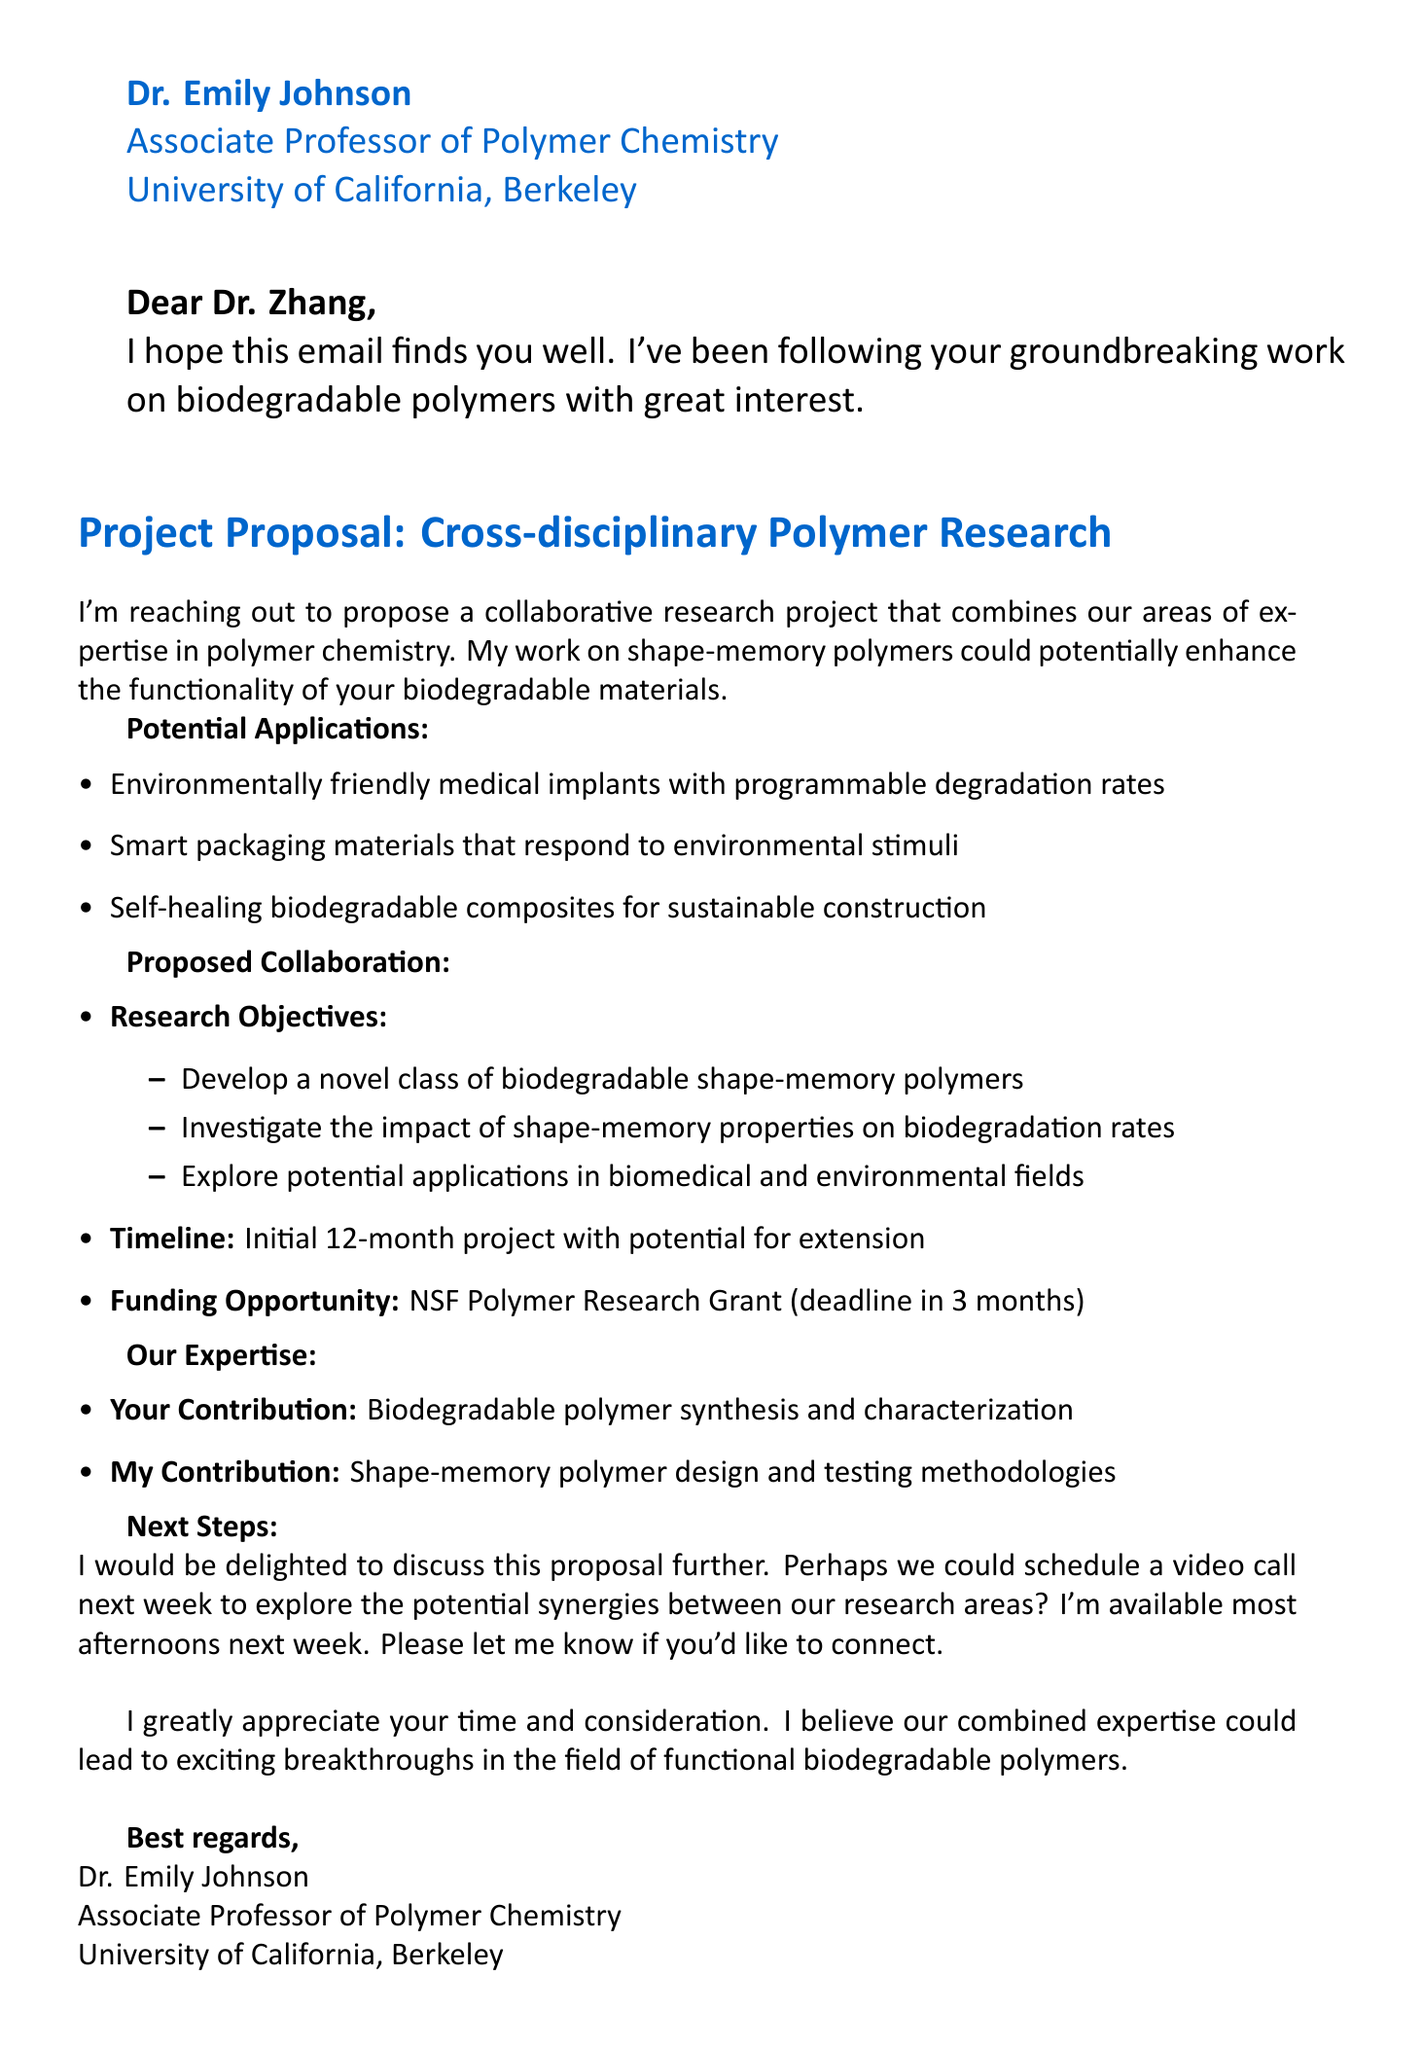What is the name of the proposed research project? The name of the proposed research project is mentioned in the title section of the document.
Answer: Cross-disciplinary Polymer Research Project: Combining Biodegradable Polymers and Smart Materials Who is the sender of the email? The sender is identified in the signature section at the end of the document.
Answer: Dr. Emily Johnson What is the funding opportunity mentioned? The funding opportunity is specified in the proposed collaboration section of the document.
Answer: NSF Polymer Research Grant How long is the initial timeline for the project? The timeline is noted in the proposed collaboration section, indicating the duration of the project.
Answer: 12 months What is one of the potential applications listed? The potential applications are outlined under the potential applications section.
Answer: Environmentally friendly medical implants with programmable degradation rates What is Dr. Zhang’s area of expertise? The email mentions Dr. Zhang's work focus, which is related to biodegradable polymers.
Answer: Biodegradable polymers What is Dr. Johnson’s contribution to the project? The sender's specific contributions are listed under the expertise section of the document.
Answer: Shape-memory polymer design and testing methodologies When is the deadline for the funding opportunity? The document specifies the timeframe associated with the funding opportunity in the proposed collaboration section.
Answer: 3 months What does Dr. Johnson suggest for the next steps? The next steps section contains Dr. Johnson's suggestion for further discussion.
Answer: Schedule a video call next week 